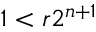Convert formula to latex. <formula><loc_0><loc_0><loc_500><loc_500>1 < r 2 ^ { n + 1 }</formula> 